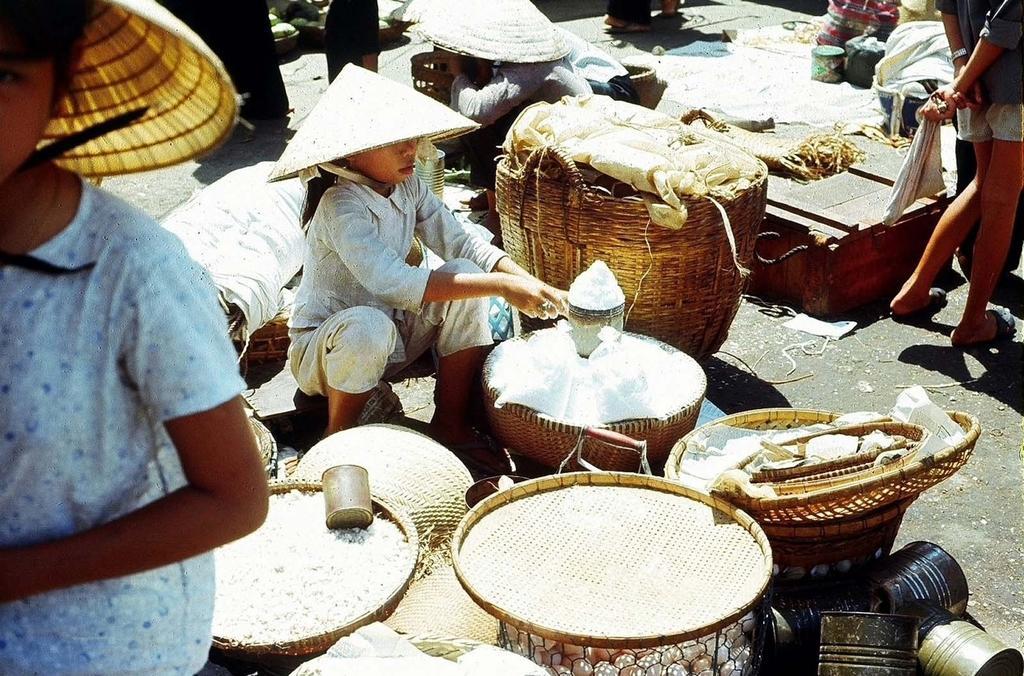Can you describe this image briefly? In this image I can see a girl sitting on the road, around her there are so many baskets with some food items and some other objects, also there are so many, also there are few people standing at the road. 